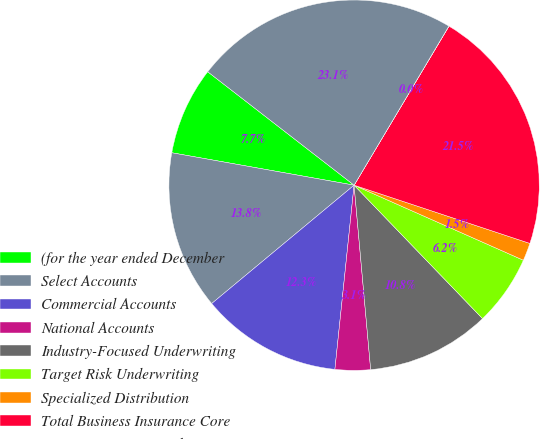Convert chart to OTSL. <chart><loc_0><loc_0><loc_500><loc_500><pie_chart><fcel>(for the year ended December<fcel>Select Accounts<fcel>Commercial Accounts<fcel>National Accounts<fcel>Industry-Focused Underwriting<fcel>Target Risk Underwriting<fcel>Specialized Distribution<fcel>Total Business Insurance Core<fcel>Business Insurance Other<fcel>Total Business Insurance<nl><fcel>7.69%<fcel>13.84%<fcel>12.31%<fcel>3.08%<fcel>10.77%<fcel>6.16%<fcel>1.55%<fcel>21.53%<fcel>0.01%<fcel>23.06%<nl></chart> 